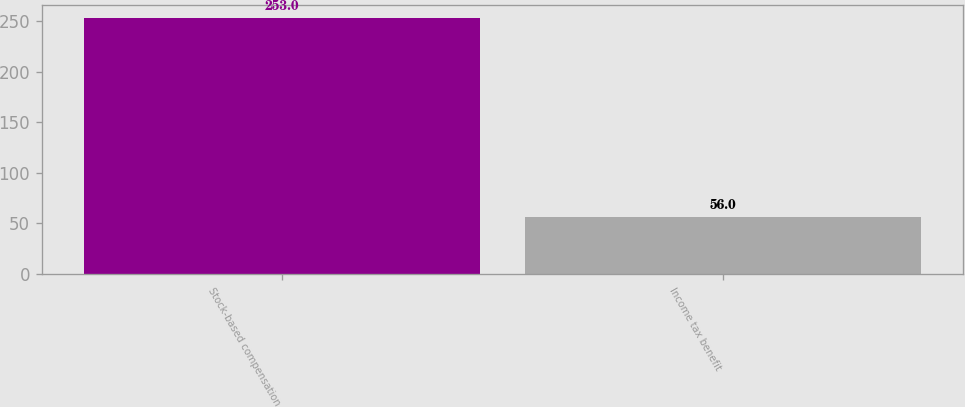<chart> <loc_0><loc_0><loc_500><loc_500><bar_chart><fcel>Stock-based compensation<fcel>Income tax benefit<nl><fcel>253<fcel>56<nl></chart> 